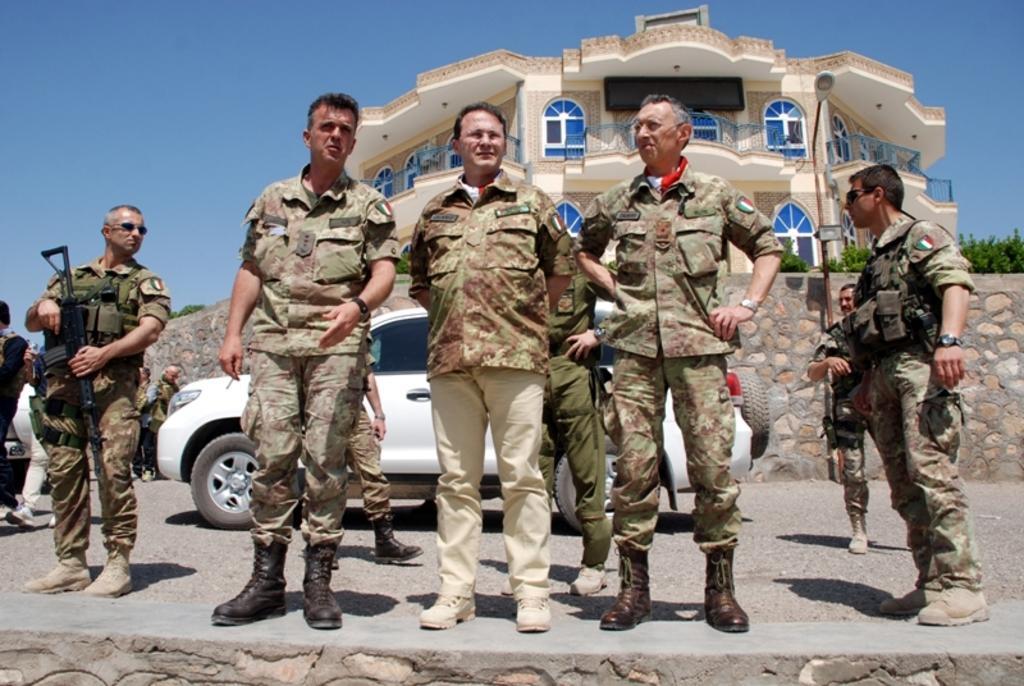Could you give a brief overview of what you see in this image? In this image I can see the group of people with military uniforms. I can see few people are holding the guns. In the background I can see the vehicles on the road. I can also see the wall, many trees, building with railing and windows and the sky. 